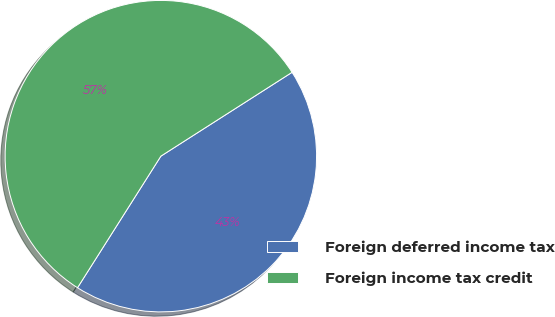<chart> <loc_0><loc_0><loc_500><loc_500><pie_chart><fcel>Foreign deferred income tax<fcel>Foreign income tax credit<nl><fcel>43.04%<fcel>56.96%<nl></chart> 